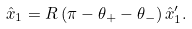Convert formula to latex. <formula><loc_0><loc_0><loc_500><loc_500>\hat { x } _ { 1 } = R \left ( \pi - \theta _ { + } - \theta _ { - } \right ) \hat { x } _ { 1 } ^ { \prime } .</formula> 